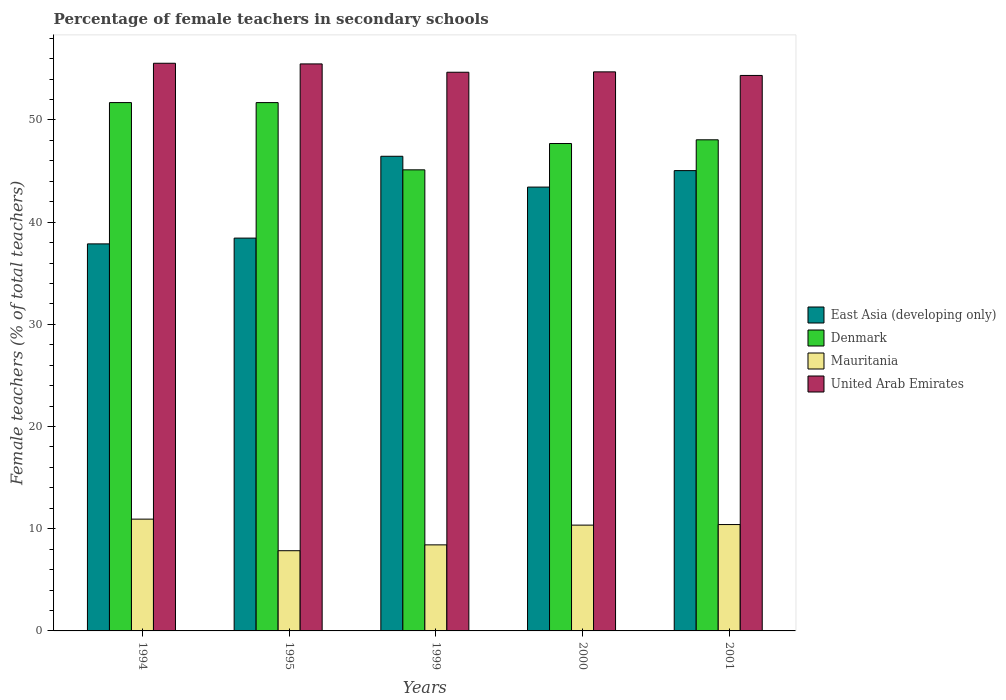What is the percentage of female teachers in United Arab Emirates in 1994?
Offer a very short reply. 55.55. Across all years, what is the maximum percentage of female teachers in Mauritania?
Your answer should be very brief. 10.94. Across all years, what is the minimum percentage of female teachers in Mauritania?
Your answer should be very brief. 7.85. In which year was the percentage of female teachers in Mauritania maximum?
Your response must be concise. 1994. What is the total percentage of female teachers in United Arab Emirates in the graph?
Your response must be concise. 274.76. What is the difference between the percentage of female teachers in Denmark in 1999 and that in 2000?
Make the answer very short. -2.57. What is the difference between the percentage of female teachers in Denmark in 2001 and the percentage of female teachers in United Arab Emirates in 1995?
Your response must be concise. -7.43. What is the average percentage of female teachers in United Arab Emirates per year?
Ensure brevity in your answer.  54.95. In the year 2000, what is the difference between the percentage of female teachers in Mauritania and percentage of female teachers in United Arab Emirates?
Keep it short and to the point. -44.35. What is the ratio of the percentage of female teachers in East Asia (developing only) in 1999 to that in 2000?
Your response must be concise. 1.07. Is the percentage of female teachers in East Asia (developing only) in 1995 less than that in 2000?
Offer a terse response. Yes. Is the difference between the percentage of female teachers in Mauritania in 2000 and 2001 greater than the difference between the percentage of female teachers in United Arab Emirates in 2000 and 2001?
Your answer should be compact. No. What is the difference between the highest and the second highest percentage of female teachers in Denmark?
Your response must be concise. 0. What is the difference between the highest and the lowest percentage of female teachers in Denmark?
Ensure brevity in your answer.  6.58. Is the sum of the percentage of female teachers in East Asia (developing only) in 1995 and 2000 greater than the maximum percentage of female teachers in Mauritania across all years?
Provide a short and direct response. Yes. What does the 4th bar from the right in 2000 represents?
Ensure brevity in your answer.  East Asia (developing only). What is the difference between two consecutive major ticks on the Y-axis?
Offer a terse response. 10. Where does the legend appear in the graph?
Provide a succinct answer. Center right. What is the title of the graph?
Make the answer very short. Percentage of female teachers in secondary schools. Does "Jamaica" appear as one of the legend labels in the graph?
Keep it short and to the point. No. What is the label or title of the X-axis?
Ensure brevity in your answer.  Years. What is the label or title of the Y-axis?
Make the answer very short. Female teachers (% of total teachers). What is the Female teachers (% of total teachers) in East Asia (developing only) in 1994?
Keep it short and to the point. 37.87. What is the Female teachers (% of total teachers) in Denmark in 1994?
Offer a very short reply. 51.7. What is the Female teachers (% of total teachers) in Mauritania in 1994?
Provide a short and direct response. 10.94. What is the Female teachers (% of total teachers) in United Arab Emirates in 1994?
Provide a succinct answer. 55.55. What is the Female teachers (% of total teachers) in East Asia (developing only) in 1995?
Provide a short and direct response. 38.44. What is the Female teachers (% of total teachers) in Denmark in 1995?
Your response must be concise. 51.7. What is the Female teachers (% of total teachers) in Mauritania in 1995?
Offer a very short reply. 7.85. What is the Female teachers (% of total teachers) in United Arab Emirates in 1995?
Make the answer very short. 55.48. What is the Female teachers (% of total teachers) of East Asia (developing only) in 1999?
Give a very brief answer. 46.44. What is the Female teachers (% of total teachers) of Denmark in 1999?
Make the answer very short. 45.12. What is the Female teachers (% of total teachers) of Mauritania in 1999?
Make the answer very short. 8.42. What is the Female teachers (% of total teachers) in United Arab Emirates in 1999?
Offer a terse response. 54.67. What is the Female teachers (% of total teachers) of East Asia (developing only) in 2000?
Offer a terse response. 43.43. What is the Female teachers (% of total teachers) in Denmark in 2000?
Give a very brief answer. 47.69. What is the Female teachers (% of total teachers) of Mauritania in 2000?
Your answer should be very brief. 10.35. What is the Female teachers (% of total teachers) in United Arab Emirates in 2000?
Provide a succinct answer. 54.7. What is the Female teachers (% of total teachers) in East Asia (developing only) in 2001?
Provide a short and direct response. 45.04. What is the Female teachers (% of total teachers) in Denmark in 2001?
Provide a succinct answer. 48.06. What is the Female teachers (% of total teachers) in Mauritania in 2001?
Offer a terse response. 10.41. What is the Female teachers (% of total teachers) in United Arab Emirates in 2001?
Give a very brief answer. 54.35. Across all years, what is the maximum Female teachers (% of total teachers) in East Asia (developing only)?
Your answer should be very brief. 46.44. Across all years, what is the maximum Female teachers (% of total teachers) in Denmark?
Make the answer very short. 51.7. Across all years, what is the maximum Female teachers (% of total teachers) in Mauritania?
Provide a succinct answer. 10.94. Across all years, what is the maximum Female teachers (% of total teachers) of United Arab Emirates?
Ensure brevity in your answer.  55.55. Across all years, what is the minimum Female teachers (% of total teachers) in East Asia (developing only)?
Offer a very short reply. 37.87. Across all years, what is the minimum Female teachers (% of total teachers) in Denmark?
Keep it short and to the point. 45.12. Across all years, what is the minimum Female teachers (% of total teachers) of Mauritania?
Your answer should be compact. 7.85. Across all years, what is the minimum Female teachers (% of total teachers) in United Arab Emirates?
Offer a terse response. 54.35. What is the total Female teachers (% of total teachers) in East Asia (developing only) in the graph?
Keep it short and to the point. 211.23. What is the total Female teachers (% of total teachers) in Denmark in the graph?
Offer a terse response. 244.26. What is the total Female teachers (% of total teachers) of Mauritania in the graph?
Make the answer very short. 47.97. What is the total Female teachers (% of total teachers) in United Arab Emirates in the graph?
Provide a succinct answer. 274.76. What is the difference between the Female teachers (% of total teachers) of East Asia (developing only) in 1994 and that in 1995?
Keep it short and to the point. -0.57. What is the difference between the Female teachers (% of total teachers) of Denmark in 1994 and that in 1995?
Your answer should be very brief. 0. What is the difference between the Female teachers (% of total teachers) in Mauritania in 1994 and that in 1995?
Provide a short and direct response. 3.09. What is the difference between the Female teachers (% of total teachers) in United Arab Emirates in 1994 and that in 1995?
Offer a very short reply. 0.06. What is the difference between the Female teachers (% of total teachers) of East Asia (developing only) in 1994 and that in 1999?
Your response must be concise. -8.57. What is the difference between the Female teachers (% of total teachers) of Denmark in 1994 and that in 1999?
Ensure brevity in your answer.  6.58. What is the difference between the Female teachers (% of total teachers) in Mauritania in 1994 and that in 1999?
Your response must be concise. 2.52. What is the difference between the Female teachers (% of total teachers) of United Arab Emirates in 1994 and that in 1999?
Your answer should be very brief. 0.88. What is the difference between the Female teachers (% of total teachers) of East Asia (developing only) in 1994 and that in 2000?
Provide a succinct answer. -5.56. What is the difference between the Female teachers (% of total teachers) of Denmark in 1994 and that in 2000?
Your response must be concise. 4. What is the difference between the Female teachers (% of total teachers) of Mauritania in 1994 and that in 2000?
Give a very brief answer. 0.59. What is the difference between the Female teachers (% of total teachers) in United Arab Emirates in 1994 and that in 2000?
Provide a succinct answer. 0.84. What is the difference between the Female teachers (% of total teachers) of East Asia (developing only) in 1994 and that in 2001?
Your answer should be very brief. -7.17. What is the difference between the Female teachers (% of total teachers) of Denmark in 1994 and that in 2001?
Make the answer very short. 3.64. What is the difference between the Female teachers (% of total teachers) of Mauritania in 1994 and that in 2001?
Your response must be concise. 0.53. What is the difference between the Female teachers (% of total teachers) in United Arab Emirates in 1994 and that in 2001?
Offer a very short reply. 1.19. What is the difference between the Female teachers (% of total teachers) in East Asia (developing only) in 1995 and that in 1999?
Keep it short and to the point. -8.01. What is the difference between the Female teachers (% of total teachers) of Denmark in 1995 and that in 1999?
Your response must be concise. 6.58. What is the difference between the Female teachers (% of total teachers) in Mauritania in 1995 and that in 1999?
Make the answer very short. -0.57. What is the difference between the Female teachers (% of total teachers) of United Arab Emirates in 1995 and that in 1999?
Offer a very short reply. 0.81. What is the difference between the Female teachers (% of total teachers) of East Asia (developing only) in 1995 and that in 2000?
Keep it short and to the point. -4.99. What is the difference between the Female teachers (% of total teachers) in Denmark in 1995 and that in 2000?
Make the answer very short. 4. What is the difference between the Female teachers (% of total teachers) in Mauritania in 1995 and that in 2000?
Keep it short and to the point. -2.5. What is the difference between the Female teachers (% of total teachers) of United Arab Emirates in 1995 and that in 2000?
Your response must be concise. 0.78. What is the difference between the Female teachers (% of total teachers) in East Asia (developing only) in 1995 and that in 2001?
Your response must be concise. -6.6. What is the difference between the Female teachers (% of total teachers) in Denmark in 1995 and that in 2001?
Give a very brief answer. 3.64. What is the difference between the Female teachers (% of total teachers) of Mauritania in 1995 and that in 2001?
Make the answer very short. -2.56. What is the difference between the Female teachers (% of total teachers) in United Arab Emirates in 1995 and that in 2001?
Give a very brief answer. 1.13. What is the difference between the Female teachers (% of total teachers) in East Asia (developing only) in 1999 and that in 2000?
Ensure brevity in your answer.  3.01. What is the difference between the Female teachers (% of total teachers) in Denmark in 1999 and that in 2000?
Offer a terse response. -2.57. What is the difference between the Female teachers (% of total teachers) in Mauritania in 1999 and that in 2000?
Ensure brevity in your answer.  -1.93. What is the difference between the Female teachers (% of total teachers) in United Arab Emirates in 1999 and that in 2000?
Provide a short and direct response. -0.04. What is the difference between the Female teachers (% of total teachers) of East Asia (developing only) in 1999 and that in 2001?
Your answer should be very brief. 1.4. What is the difference between the Female teachers (% of total teachers) of Denmark in 1999 and that in 2001?
Offer a terse response. -2.94. What is the difference between the Female teachers (% of total teachers) of Mauritania in 1999 and that in 2001?
Your answer should be very brief. -1.99. What is the difference between the Female teachers (% of total teachers) in United Arab Emirates in 1999 and that in 2001?
Keep it short and to the point. 0.31. What is the difference between the Female teachers (% of total teachers) in East Asia (developing only) in 2000 and that in 2001?
Ensure brevity in your answer.  -1.61. What is the difference between the Female teachers (% of total teachers) in Denmark in 2000 and that in 2001?
Keep it short and to the point. -0.36. What is the difference between the Female teachers (% of total teachers) of Mauritania in 2000 and that in 2001?
Your answer should be very brief. -0.06. What is the difference between the Female teachers (% of total teachers) in United Arab Emirates in 2000 and that in 2001?
Your answer should be compact. 0.35. What is the difference between the Female teachers (% of total teachers) in East Asia (developing only) in 1994 and the Female teachers (% of total teachers) in Denmark in 1995?
Ensure brevity in your answer.  -13.82. What is the difference between the Female teachers (% of total teachers) of East Asia (developing only) in 1994 and the Female teachers (% of total teachers) of Mauritania in 1995?
Offer a terse response. 30.02. What is the difference between the Female teachers (% of total teachers) in East Asia (developing only) in 1994 and the Female teachers (% of total teachers) in United Arab Emirates in 1995?
Your response must be concise. -17.61. What is the difference between the Female teachers (% of total teachers) of Denmark in 1994 and the Female teachers (% of total teachers) of Mauritania in 1995?
Offer a very short reply. 43.85. What is the difference between the Female teachers (% of total teachers) of Denmark in 1994 and the Female teachers (% of total teachers) of United Arab Emirates in 1995?
Offer a very short reply. -3.78. What is the difference between the Female teachers (% of total teachers) in Mauritania in 1994 and the Female teachers (% of total teachers) in United Arab Emirates in 1995?
Give a very brief answer. -44.54. What is the difference between the Female teachers (% of total teachers) in East Asia (developing only) in 1994 and the Female teachers (% of total teachers) in Denmark in 1999?
Offer a very short reply. -7.25. What is the difference between the Female teachers (% of total teachers) of East Asia (developing only) in 1994 and the Female teachers (% of total teachers) of Mauritania in 1999?
Your response must be concise. 29.45. What is the difference between the Female teachers (% of total teachers) of East Asia (developing only) in 1994 and the Female teachers (% of total teachers) of United Arab Emirates in 1999?
Offer a terse response. -16.8. What is the difference between the Female teachers (% of total teachers) of Denmark in 1994 and the Female teachers (% of total teachers) of Mauritania in 1999?
Provide a short and direct response. 43.28. What is the difference between the Female teachers (% of total teachers) in Denmark in 1994 and the Female teachers (% of total teachers) in United Arab Emirates in 1999?
Your answer should be very brief. -2.97. What is the difference between the Female teachers (% of total teachers) of Mauritania in 1994 and the Female teachers (% of total teachers) of United Arab Emirates in 1999?
Your response must be concise. -43.73. What is the difference between the Female teachers (% of total teachers) of East Asia (developing only) in 1994 and the Female teachers (% of total teachers) of Denmark in 2000?
Provide a short and direct response. -9.82. What is the difference between the Female teachers (% of total teachers) in East Asia (developing only) in 1994 and the Female teachers (% of total teachers) in Mauritania in 2000?
Make the answer very short. 27.52. What is the difference between the Female teachers (% of total teachers) of East Asia (developing only) in 1994 and the Female teachers (% of total teachers) of United Arab Emirates in 2000?
Your answer should be compact. -16.83. What is the difference between the Female teachers (% of total teachers) of Denmark in 1994 and the Female teachers (% of total teachers) of Mauritania in 2000?
Keep it short and to the point. 41.34. What is the difference between the Female teachers (% of total teachers) of Denmark in 1994 and the Female teachers (% of total teachers) of United Arab Emirates in 2000?
Your answer should be compact. -3.01. What is the difference between the Female teachers (% of total teachers) of Mauritania in 1994 and the Female teachers (% of total teachers) of United Arab Emirates in 2000?
Ensure brevity in your answer.  -43.77. What is the difference between the Female teachers (% of total teachers) in East Asia (developing only) in 1994 and the Female teachers (% of total teachers) in Denmark in 2001?
Offer a very short reply. -10.18. What is the difference between the Female teachers (% of total teachers) in East Asia (developing only) in 1994 and the Female teachers (% of total teachers) in Mauritania in 2001?
Your response must be concise. 27.46. What is the difference between the Female teachers (% of total teachers) in East Asia (developing only) in 1994 and the Female teachers (% of total teachers) in United Arab Emirates in 2001?
Offer a terse response. -16.48. What is the difference between the Female teachers (% of total teachers) in Denmark in 1994 and the Female teachers (% of total teachers) in Mauritania in 2001?
Your answer should be very brief. 41.29. What is the difference between the Female teachers (% of total teachers) of Denmark in 1994 and the Female teachers (% of total teachers) of United Arab Emirates in 2001?
Your answer should be very brief. -2.66. What is the difference between the Female teachers (% of total teachers) in Mauritania in 1994 and the Female teachers (% of total teachers) in United Arab Emirates in 2001?
Your answer should be very brief. -43.41. What is the difference between the Female teachers (% of total teachers) in East Asia (developing only) in 1995 and the Female teachers (% of total teachers) in Denmark in 1999?
Provide a succinct answer. -6.68. What is the difference between the Female teachers (% of total teachers) of East Asia (developing only) in 1995 and the Female teachers (% of total teachers) of Mauritania in 1999?
Provide a short and direct response. 30.02. What is the difference between the Female teachers (% of total teachers) in East Asia (developing only) in 1995 and the Female teachers (% of total teachers) in United Arab Emirates in 1999?
Provide a succinct answer. -16.23. What is the difference between the Female teachers (% of total teachers) in Denmark in 1995 and the Female teachers (% of total teachers) in Mauritania in 1999?
Ensure brevity in your answer.  43.28. What is the difference between the Female teachers (% of total teachers) of Denmark in 1995 and the Female teachers (% of total teachers) of United Arab Emirates in 1999?
Keep it short and to the point. -2.97. What is the difference between the Female teachers (% of total teachers) of Mauritania in 1995 and the Female teachers (% of total teachers) of United Arab Emirates in 1999?
Provide a succinct answer. -46.82. What is the difference between the Female teachers (% of total teachers) of East Asia (developing only) in 1995 and the Female teachers (% of total teachers) of Denmark in 2000?
Give a very brief answer. -9.26. What is the difference between the Female teachers (% of total teachers) of East Asia (developing only) in 1995 and the Female teachers (% of total teachers) of Mauritania in 2000?
Ensure brevity in your answer.  28.09. What is the difference between the Female teachers (% of total teachers) in East Asia (developing only) in 1995 and the Female teachers (% of total teachers) in United Arab Emirates in 2000?
Provide a succinct answer. -16.27. What is the difference between the Female teachers (% of total teachers) in Denmark in 1995 and the Female teachers (% of total teachers) in Mauritania in 2000?
Provide a succinct answer. 41.34. What is the difference between the Female teachers (% of total teachers) in Denmark in 1995 and the Female teachers (% of total teachers) in United Arab Emirates in 2000?
Offer a very short reply. -3.01. What is the difference between the Female teachers (% of total teachers) of Mauritania in 1995 and the Female teachers (% of total teachers) of United Arab Emirates in 2000?
Keep it short and to the point. -46.86. What is the difference between the Female teachers (% of total teachers) in East Asia (developing only) in 1995 and the Female teachers (% of total teachers) in Denmark in 2001?
Your response must be concise. -9.62. What is the difference between the Female teachers (% of total teachers) in East Asia (developing only) in 1995 and the Female teachers (% of total teachers) in Mauritania in 2001?
Offer a terse response. 28.03. What is the difference between the Female teachers (% of total teachers) in East Asia (developing only) in 1995 and the Female teachers (% of total teachers) in United Arab Emirates in 2001?
Your answer should be very brief. -15.92. What is the difference between the Female teachers (% of total teachers) in Denmark in 1995 and the Female teachers (% of total teachers) in Mauritania in 2001?
Offer a very short reply. 41.29. What is the difference between the Female teachers (% of total teachers) in Denmark in 1995 and the Female teachers (% of total teachers) in United Arab Emirates in 2001?
Give a very brief answer. -2.66. What is the difference between the Female teachers (% of total teachers) in Mauritania in 1995 and the Female teachers (% of total teachers) in United Arab Emirates in 2001?
Ensure brevity in your answer.  -46.5. What is the difference between the Female teachers (% of total teachers) of East Asia (developing only) in 1999 and the Female teachers (% of total teachers) of Denmark in 2000?
Keep it short and to the point. -1.25. What is the difference between the Female teachers (% of total teachers) in East Asia (developing only) in 1999 and the Female teachers (% of total teachers) in Mauritania in 2000?
Ensure brevity in your answer.  36.09. What is the difference between the Female teachers (% of total teachers) in East Asia (developing only) in 1999 and the Female teachers (% of total teachers) in United Arab Emirates in 2000?
Give a very brief answer. -8.26. What is the difference between the Female teachers (% of total teachers) of Denmark in 1999 and the Female teachers (% of total teachers) of Mauritania in 2000?
Make the answer very short. 34.77. What is the difference between the Female teachers (% of total teachers) in Denmark in 1999 and the Female teachers (% of total teachers) in United Arab Emirates in 2000?
Keep it short and to the point. -9.59. What is the difference between the Female teachers (% of total teachers) of Mauritania in 1999 and the Female teachers (% of total teachers) of United Arab Emirates in 2000?
Your answer should be very brief. -46.28. What is the difference between the Female teachers (% of total teachers) of East Asia (developing only) in 1999 and the Female teachers (% of total teachers) of Denmark in 2001?
Provide a short and direct response. -1.61. What is the difference between the Female teachers (% of total teachers) of East Asia (developing only) in 1999 and the Female teachers (% of total teachers) of Mauritania in 2001?
Your answer should be very brief. 36.04. What is the difference between the Female teachers (% of total teachers) in East Asia (developing only) in 1999 and the Female teachers (% of total teachers) in United Arab Emirates in 2001?
Ensure brevity in your answer.  -7.91. What is the difference between the Female teachers (% of total teachers) of Denmark in 1999 and the Female teachers (% of total teachers) of Mauritania in 2001?
Give a very brief answer. 34.71. What is the difference between the Female teachers (% of total teachers) of Denmark in 1999 and the Female teachers (% of total teachers) of United Arab Emirates in 2001?
Your answer should be compact. -9.24. What is the difference between the Female teachers (% of total teachers) of Mauritania in 1999 and the Female teachers (% of total teachers) of United Arab Emirates in 2001?
Provide a short and direct response. -45.93. What is the difference between the Female teachers (% of total teachers) in East Asia (developing only) in 2000 and the Female teachers (% of total teachers) in Denmark in 2001?
Make the answer very short. -4.63. What is the difference between the Female teachers (% of total teachers) in East Asia (developing only) in 2000 and the Female teachers (% of total teachers) in Mauritania in 2001?
Give a very brief answer. 33.02. What is the difference between the Female teachers (% of total teachers) in East Asia (developing only) in 2000 and the Female teachers (% of total teachers) in United Arab Emirates in 2001?
Offer a very short reply. -10.92. What is the difference between the Female teachers (% of total teachers) of Denmark in 2000 and the Female teachers (% of total teachers) of Mauritania in 2001?
Ensure brevity in your answer.  37.28. What is the difference between the Female teachers (% of total teachers) in Denmark in 2000 and the Female teachers (% of total teachers) in United Arab Emirates in 2001?
Your answer should be compact. -6.66. What is the difference between the Female teachers (% of total teachers) of Mauritania in 2000 and the Female teachers (% of total teachers) of United Arab Emirates in 2001?
Your response must be concise. -44. What is the average Female teachers (% of total teachers) in East Asia (developing only) per year?
Your response must be concise. 42.25. What is the average Female teachers (% of total teachers) in Denmark per year?
Provide a succinct answer. 48.85. What is the average Female teachers (% of total teachers) of Mauritania per year?
Offer a very short reply. 9.59. What is the average Female teachers (% of total teachers) of United Arab Emirates per year?
Ensure brevity in your answer.  54.95. In the year 1994, what is the difference between the Female teachers (% of total teachers) of East Asia (developing only) and Female teachers (% of total teachers) of Denmark?
Keep it short and to the point. -13.83. In the year 1994, what is the difference between the Female teachers (% of total teachers) of East Asia (developing only) and Female teachers (% of total teachers) of Mauritania?
Provide a short and direct response. 26.93. In the year 1994, what is the difference between the Female teachers (% of total teachers) in East Asia (developing only) and Female teachers (% of total teachers) in United Arab Emirates?
Make the answer very short. -17.67. In the year 1994, what is the difference between the Female teachers (% of total teachers) in Denmark and Female teachers (% of total teachers) in Mauritania?
Provide a succinct answer. 40.76. In the year 1994, what is the difference between the Female teachers (% of total teachers) in Denmark and Female teachers (% of total teachers) in United Arab Emirates?
Make the answer very short. -3.85. In the year 1994, what is the difference between the Female teachers (% of total teachers) in Mauritania and Female teachers (% of total teachers) in United Arab Emirates?
Ensure brevity in your answer.  -44.61. In the year 1995, what is the difference between the Female teachers (% of total teachers) of East Asia (developing only) and Female teachers (% of total teachers) of Denmark?
Provide a short and direct response. -13.26. In the year 1995, what is the difference between the Female teachers (% of total teachers) in East Asia (developing only) and Female teachers (% of total teachers) in Mauritania?
Your answer should be very brief. 30.59. In the year 1995, what is the difference between the Female teachers (% of total teachers) of East Asia (developing only) and Female teachers (% of total teachers) of United Arab Emirates?
Offer a very short reply. -17.04. In the year 1995, what is the difference between the Female teachers (% of total teachers) in Denmark and Female teachers (% of total teachers) in Mauritania?
Your response must be concise. 43.85. In the year 1995, what is the difference between the Female teachers (% of total teachers) in Denmark and Female teachers (% of total teachers) in United Arab Emirates?
Provide a short and direct response. -3.79. In the year 1995, what is the difference between the Female teachers (% of total teachers) of Mauritania and Female teachers (% of total teachers) of United Arab Emirates?
Offer a very short reply. -47.63. In the year 1999, what is the difference between the Female teachers (% of total teachers) in East Asia (developing only) and Female teachers (% of total teachers) in Denmark?
Offer a terse response. 1.33. In the year 1999, what is the difference between the Female teachers (% of total teachers) in East Asia (developing only) and Female teachers (% of total teachers) in Mauritania?
Your response must be concise. 38.02. In the year 1999, what is the difference between the Female teachers (% of total teachers) in East Asia (developing only) and Female teachers (% of total teachers) in United Arab Emirates?
Your answer should be very brief. -8.22. In the year 1999, what is the difference between the Female teachers (% of total teachers) of Denmark and Female teachers (% of total teachers) of Mauritania?
Your response must be concise. 36.7. In the year 1999, what is the difference between the Female teachers (% of total teachers) in Denmark and Female teachers (% of total teachers) in United Arab Emirates?
Make the answer very short. -9.55. In the year 1999, what is the difference between the Female teachers (% of total teachers) in Mauritania and Female teachers (% of total teachers) in United Arab Emirates?
Ensure brevity in your answer.  -46.25. In the year 2000, what is the difference between the Female teachers (% of total teachers) of East Asia (developing only) and Female teachers (% of total teachers) of Denmark?
Make the answer very short. -4.26. In the year 2000, what is the difference between the Female teachers (% of total teachers) of East Asia (developing only) and Female teachers (% of total teachers) of Mauritania?
Provide a succinct answer. 33.08. In the year 2000, what is the difference between the Female teachers (% of total teachers) of East Asia (developing only) and Female teachers (% of total teachers) of United Arab Emirates?
Provide a succinct answer. -11.27. In the year 2000, what is the difference between the Female teachers (% of total teachers) of Denmark and Female teachers (% of total teachers) of Mauritania?
Your answer should be compact. 37.34. In the year 2000, what is the difference between the Female teachers (% of total teachers) of Denmark and Female teachers (% of total teachers) of United Arab Emirates?
Ensure brevity in your answer.  -7.01. In the year 2000, what is the difference between the Female teachers (% of total teachers) in Mauritania and Female teachers (% of total teachers) in United Arab Emirates?
Your answer should be compact. -44.35. In the year 2001, what is the difference between the Female teachers (% of total teachers) of East Asia (developing only) and Female teachers (% of total teachers) of Denmark?
Offer a very short reply. -3.01. In the year 2001, what is the difference between the Female teachers (% of total teachers) in East Asia (developing only) and Female teachers (% of total teachers) in Mauritania?
Offer a very short reply. 34.63. In the year 2001, what is the difference between the Female teachers (% of total teachers) in East Asia (developing only) and Female teachers (% of total teachers) in United Arab Emirates?
Your answer should be compact. -9.31. In the year 2001, what is the difference between the Female teachers (% of total teachers) of Denmark and Female teachers (% of total teachers) of Mauritania?
Your answer should be very brief. 37.65. In the year 2001, what is the difference between the Female teachers (% of total teachers) of Denmark and Female teachers (% of total teachers) of United Arab Emirates?
Provide a succinct answer. -6.3. In the year 2001, what is the difference between the Female teachers (% of total teachers) of Mauritania and Female teachers (% of total teachers) of United Arab Emirates?
Make the answer very short. -43.95. What is the ratio of the Female teachers (% of total teachers) in Denmark in 1994 to that in 1995?
Your answer should be compact. 1. What is the ratio of the Female teachers (% of total teachers) of Mauritania in 1994 to that in 1995?
Provide a short and direct response. 1.39. What is the ratio of the Female teachers (% of total teachers) in United Arab Emirates in 1994 to that in 1995?
Keep it short and to the point. 1. What is the ratio of the Female teachers (% of total teachers) in East Asia (developing only) in 1994 to that in 1999?
Your answer should be very brief. 0.82. What is the ratio of the Female teachers (% of total teachers) in Denmark in 1994 to that in 1999?
Offer a very short reply. 1.15. What is the ratio of the Female teachers (% of total teachers) in Mauritania in 1994 to that in 1999?
Provide a succinct answer. 1.3. What is the ratio of the Female teachers (% of total teachers) in United Arab Emirates in 1994 to that in 1999?
Keep it short and to the point. 1.02. What is the ratio of the Female teachers (% of total teachers) of East Asia (developing only) in 1994 to that in 2000?
Give a very brief answer. 0.87. What is the ratio of the Female teachers (% of total teachers) in Denmark in 1994 to that in 2000?
Make the answer very short. 1.08. What is the ratio of the Female teachers (% of total teachers) in Mauritania in 1994 to that in 2000?
Keep it short and to the point. 1.06. What is the ratio of the Female teachers (% of total teachers) of United Arab Emirates in 1994 to that in 2000?
Your response must be concise. 1.02. What is the ratio of the Female teachers (% of total teachers) in East Asia (developing only) in 1994 to that in 2001?
Your answer should be very brief. 0.84. What is the ratio of the Female teachers (% of total teachers) of Denmark in 1994 to that in 2001?
Keep it short and to the point. 1.08. What is the ratio of the Female teachers (% of total teachers) in Mauritania in 1994 to that in 2001?
Make the answer very short. 1.05. What is the ratio of the Female teachers (% of total teachers) in United Arab Emirates in 1994 to that in 2001?
Offer a very short reply. 1.02. What is the ratio of the Female teachers (% of total teachers) in East Asia (developing only) in 1995 to that in 1999?
Your response must be concise. 0.83. What is the ratio of the Female teachers (% of total teachers) of Denmark in 1995 to that in 1999?
Your answer should be very brief. 1.15. What is the ratio of the Female teachers (% of total teachers) in Mauritania in 1995 to that in 1999?
Offer a very short reply. 0.93. What is the ratio of the Female teachers (% of total teachers) of United Arab Emirates in 1995 to that in 1999?
Make the answer very short. 1.01. What is the ratio of the Female teachers (% of total teachers) in East Asia (developing only) in 1995 to that in 2000?
Keep it short and to the point. 0.89. What is the ratio of the Female teachers (% of total teachers) of Denmark in 1995 to that in 2000?
Provide a succinct answer. 1.08. What is the ratio of the Female teachers (% of total teachers) of Mauritania in 1995 to that in 2000?
Make the answer very short. 0.76. What is the ratio of the Female teachers (% of total teachers) of United Arab Emirates in 1995 to that in 2000?
Give a very brief answer. 1.01. What is the ratio of the Female teachers (% of total teachers) of East Asia (developing only) in 1995 to that in 2001?
Your answer should be compact. 0.85. What is the ratio of the Female teachers (% of total teachers) in Denmark in 1995 to that in 2001?
Offer a very short reply. 1.08. What is the ratio of the Female teachers (% of total teachers) in Mauritania in 1995 to that in 2001?
Give a very brief answer. 0.75. What is the ratio of the Female teachers (% of total teachers) of United Arab Emirates in 1995 to that in 2001?
Provide a succinct answer. 1.02. What is the ratio of the Female teachers (% of total teachers) in East Asia (developing only) in 1999 to that in 2000?
Ensure brevity in your answer.  1.07. What is the ratio of the Female teachers (% of total teachers) in Denmark in 1999 to that in 2000?
Give a very brief answer. 0.95. What is the ratio of the Female teachers (% of total teachers) in Mauritania in 1999 to that in 2000?
Keep it short and to the point. 0.81. What is the ratio of the Female teachers (% of total teachers) of East Asia (developing only) in 1999 to that in 2001?
Give a very brief answer. 1.03. What is the ratio of the Female teachers (% of total teachers) of Denmark in 1999 to that in 2001?
Make the answer very short. 0.94. What is the ratio of the Female teachers (% of total teachers) of Mauritania in 1999 to that in 2001?
Your answer should be very brief. 0.81. What is the ratio of the Female teachers (% of total teachers) of East Asia (developing only) in 2000 to that in 2001?
Your response must be concise. 0.96. What is the ratio of the Female teachers (% of total teachers) of United Arab Emirates in 2000 to that in 2001?
Your answer should be very brief. 1.01. What is the difference between the highest and the second highest Female teachers (% of total teachers) of East Asia (developing only)?
Your response must be concise. 1.4. What is the difference between the highest and the second highest Female teachers (% of total teachers) of Denmark?
Keep it short and to the point. 0. What is the difference between the highest and the second highest Female teachers (% of total teachers) in Mauritania?
Give a very brief answer. 0.53. What is the difference between the highest and the second highest Female teachers (% of total teachers) of United Arab Emirates?
Your answer should be compact. 0.06. What is the difference between the highest and the lowest Female teachers (% of total teachers) of East Asia (developing only)?
Your answer should be compact. 8.57. What is the difference between the highest and the lowest Female teachers (% of total teachers) of Denmark?
Offer a very short reply. 6.58. What is the difference between the highest and the lowest Female teachers (% of total teachers) of Mauritania?
Provide a succinct answer. 3.09. What is the difference between the highest and the lowest Female teachers (% of total teachers) in United Arab Emirates?
Your response must be concise. 1.19. 